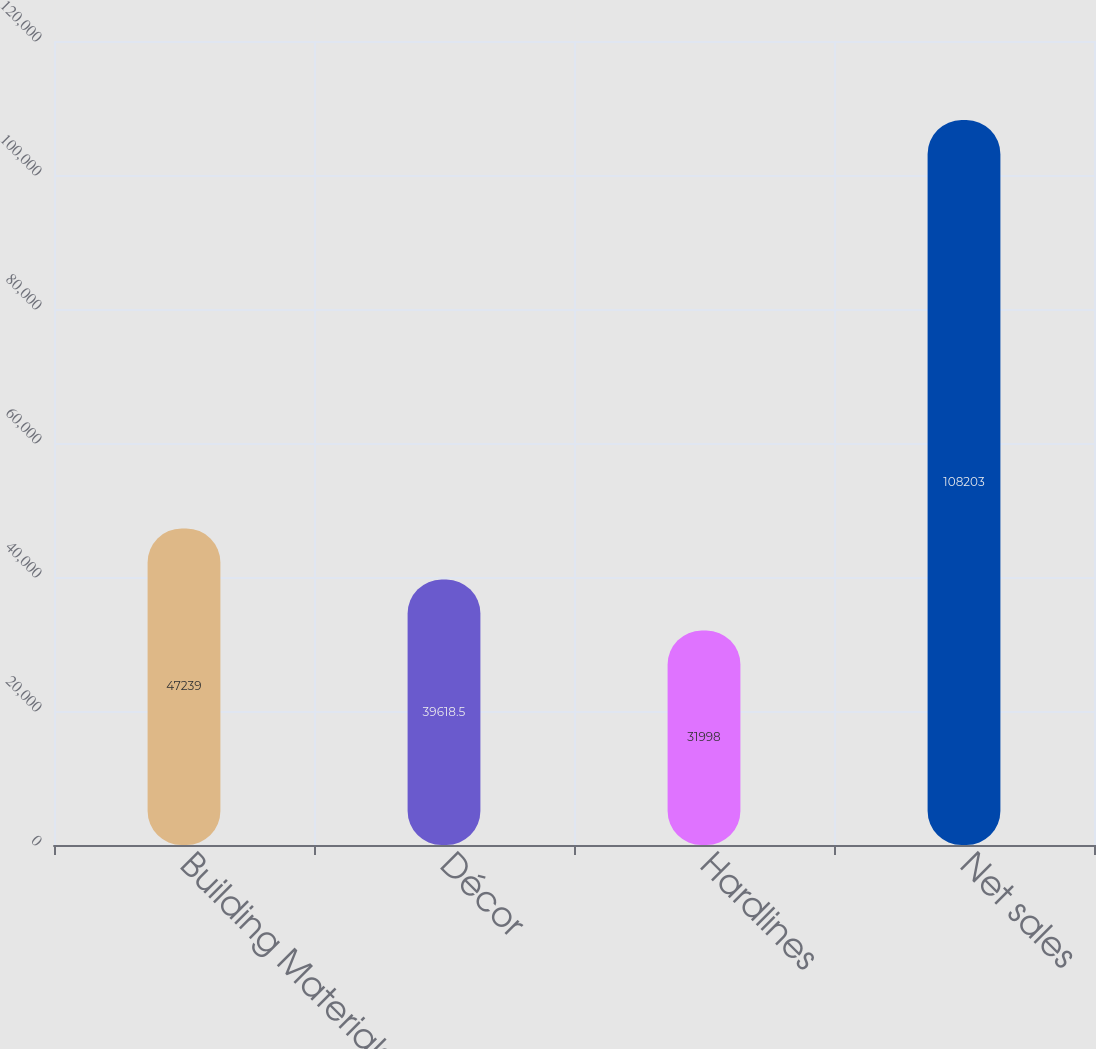<chart> <loc_0><loc_0><loc_500><loc_500><bar_chart><fcel>Building Materials<fcel>Décor<fcel>Hardlines<fcel>Net sales<nl><fcel>47239<fcel>39618.5<fcel>31998<fcel>108203<nl></chart> 